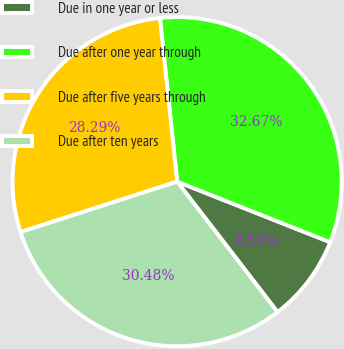<chart> <loc_0><loc_0><loc_500><loc_500><pie_chart><fcel>Due in one year or less<fcel>Due after one year through<fcel>Due after five years through<fcel>Due after ten years<nl><fcel>8.56%<fcel>32.67%<fcel>28.29%<fcel>30.48%<nl></chart> 